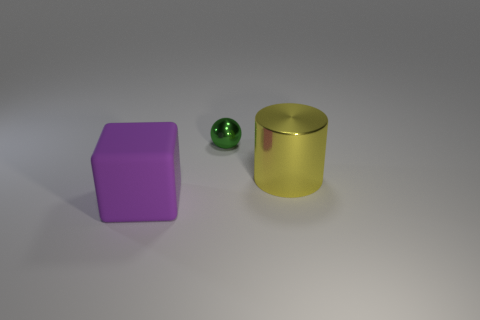Are there more large rubber blocks than tiny green matte things? Yes, there is indeed a greater quantity of large rubber blocks, as we can see one large purple rubber block present in the image, compared to only a single small green matte object. 